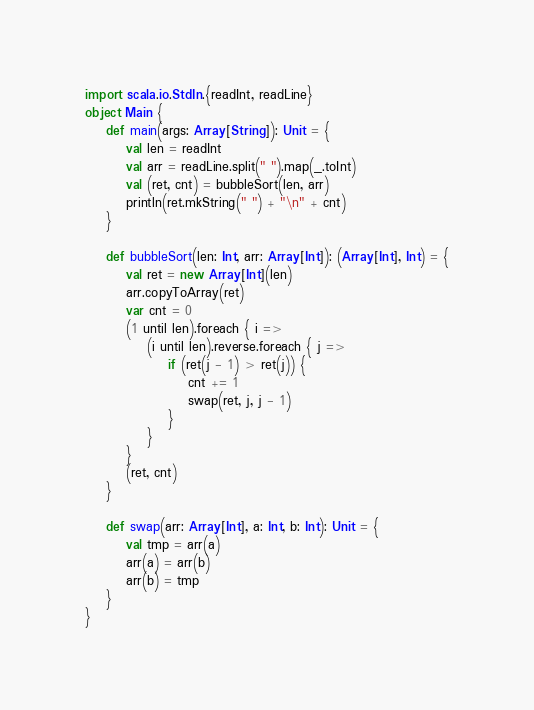<code> <loc_0><loc_0><loc_500><loc_500><_Scala_>import scala.io.StdIn.{readInt, readLine}
object Main {
    def main(args: Array[String]): Unit = {
        val len = readInt
        val arr = readLine.split(" ").map(_.toInt)
        val (ret, cnt) = bubbleSort(len, arr)
        println(ret.mkString(" ") + "\n" + cnt)
    }
    
    def bubbleSort(len: Int, arr: Array[Int]): (Array[Int], Int) = {
        val ret = new Array[Int](len)
        arr.copyToArray(ret)
        var cnt = 0
        (1 until len).foreach { i =>
            (i until len).reverse.foreach { j =>
                if (ret(j - 1) > ret(j)) {
                    cnt += 1
                    swap(ret, j, j - 1)
                }
            }
        }
        (ret, cnt)
    }
    
    def swap(arr: Array[Int], a: Int, b: Int): Unit = {
        val tmp = arr(a)
        arr(a) = arr(b)
        arr(b) = tmp
    }
}
</code> 